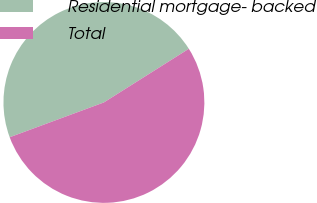<chart> <loc_0><loc_0><loc_500><loc_500><pie_chart><fcel>Residential mortgage- backed<fcel>Total<nl><fcel>46.67%<fcel>53.33%<nl></chart> 